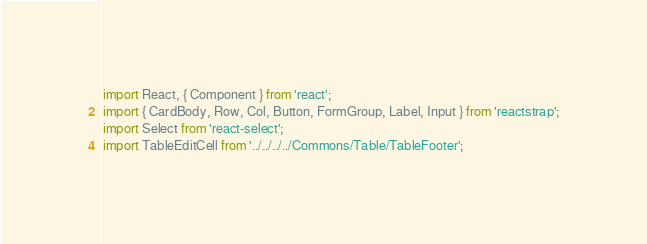Convert code to text. <code><loc_0><loc_0><loc_500><loc_500><_JavaScript_>import React, { Component } from 'react';
import { CardBody, Row, Col, Button, FormGroup, Label, Input } from 'reactstrap';
import Select from 'react-select';
import TableEditCell from '../../../../Commons/Table/TableFooter';</code> 